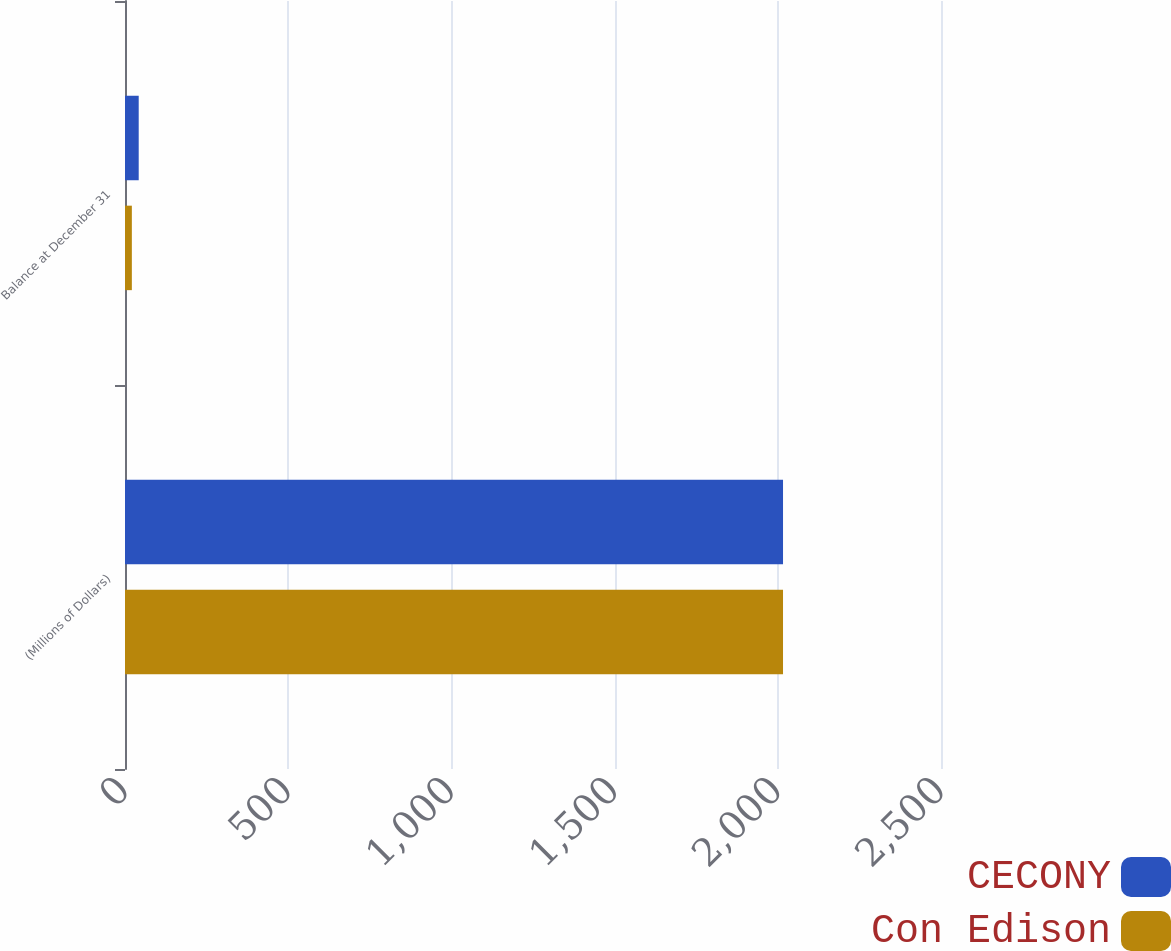Convert chart. <chart><loc_0><loc_0><loc_500><loc_500><stacked_bar_chart><ecel><fcel>(Millions of Dollars)<fcel>Balance at December 31<nl><fcel>CECONY<fcel>2016<fcel>42<nl><fcel>Con Edison<fcel>2016<fcel>21<nl></chart> 